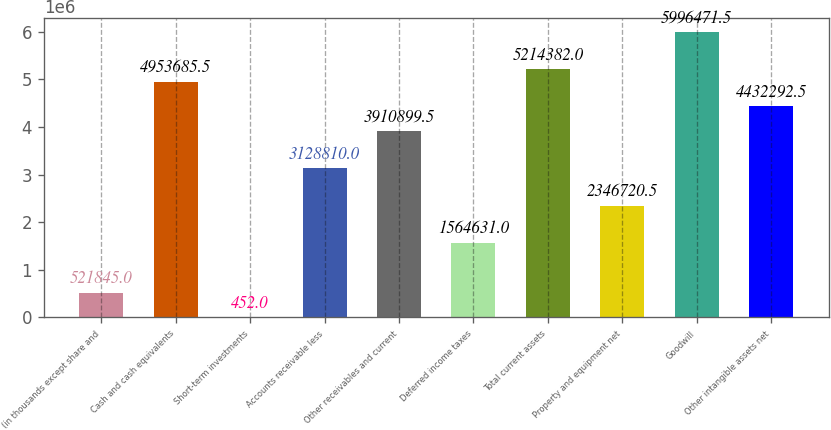Convert chart. <chart><loc_0><loc_0><loc_500><loc_500><bar_chart><fcel>(in thousands except share and<fcel>Cash and cash equivalents<fcel>Short-term investments<fcel>Accounts receivable less<fcel>Other receivables and current<fcel>Deferred income taxes<fcel>Total current assets<fcel>Property and equipment net<fcel>Goodwill<fcel>Other intangible assets net<nl><fcel>521845<fcel>4.95369e+06<fcel>452<fcel>3.12881e+06<fcel>3.9109e+06<fcel>1.56463e+06<fcel>5.21438e+06<fcel>2.34672e+06<fcel>5.99647e+06<fcel>4.43229e+06<nl></chart> 